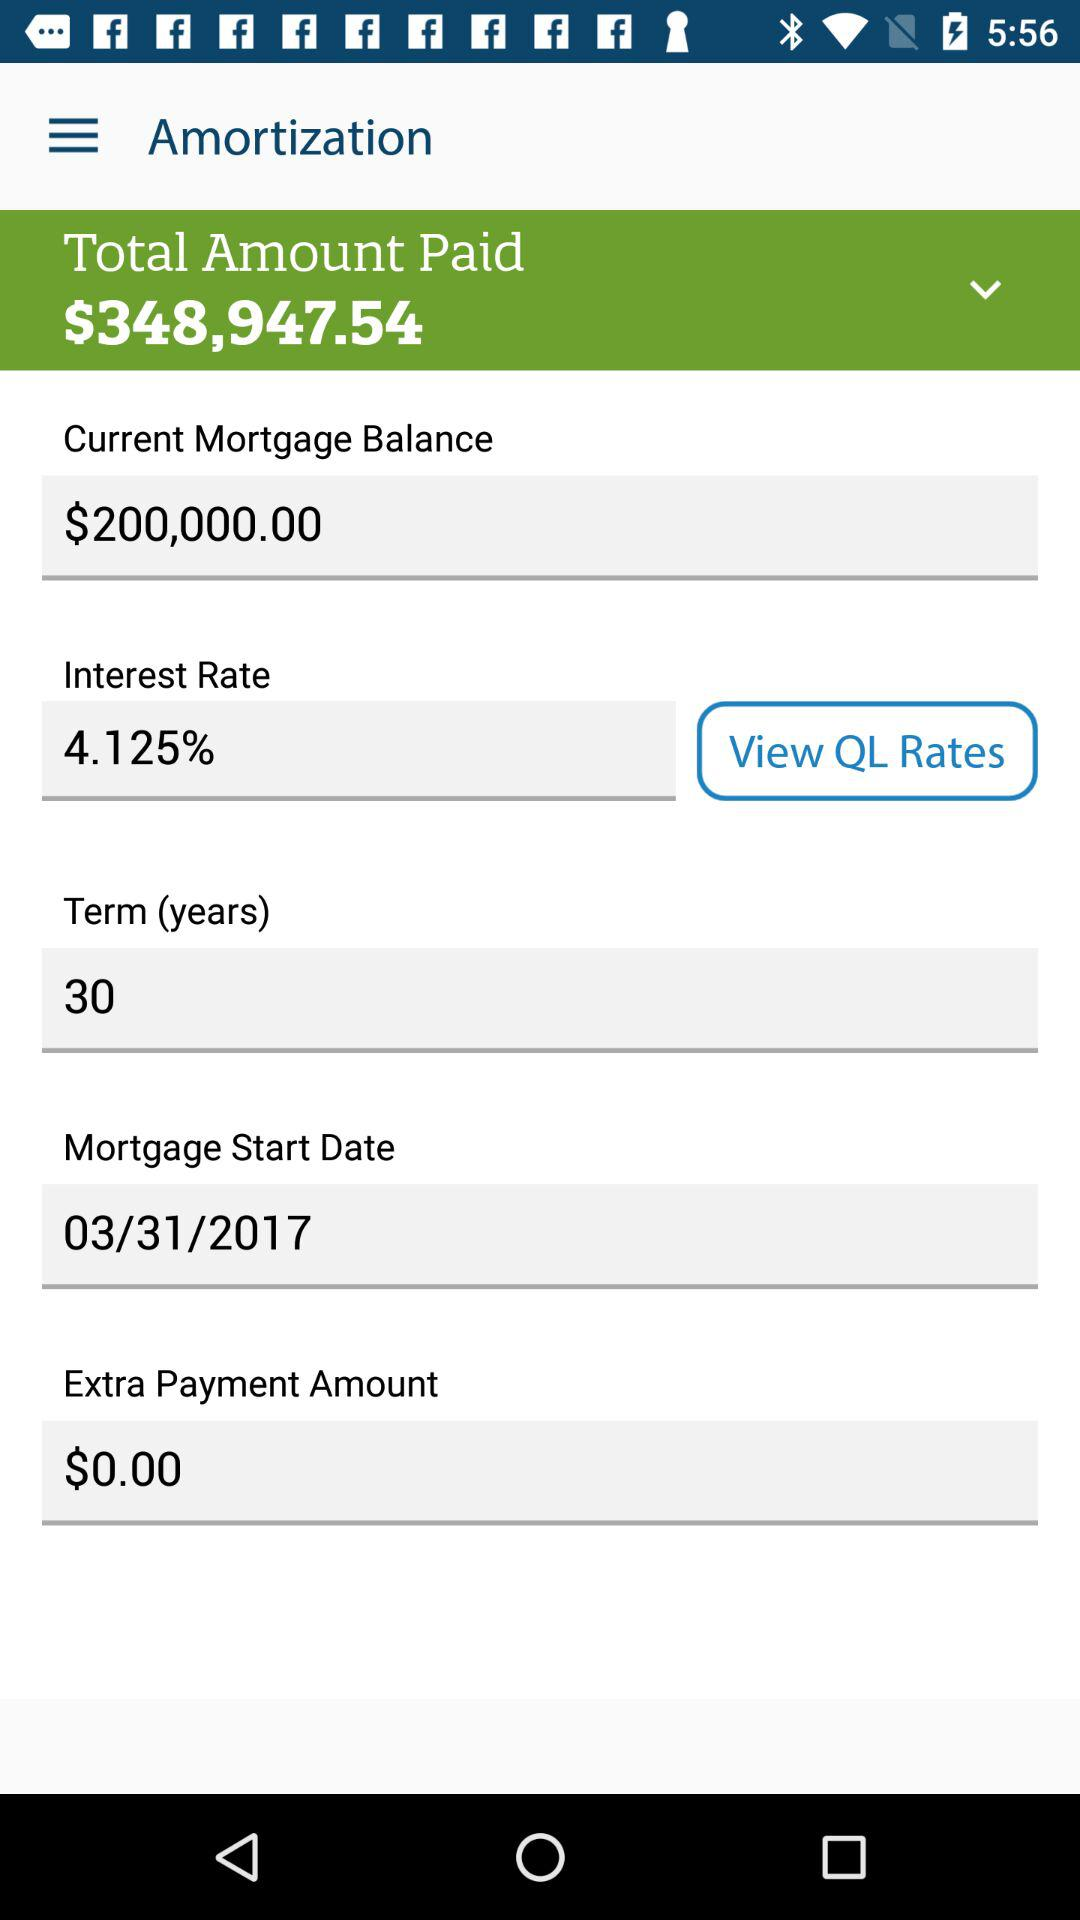What is the app name? The app name is "Amortization". 